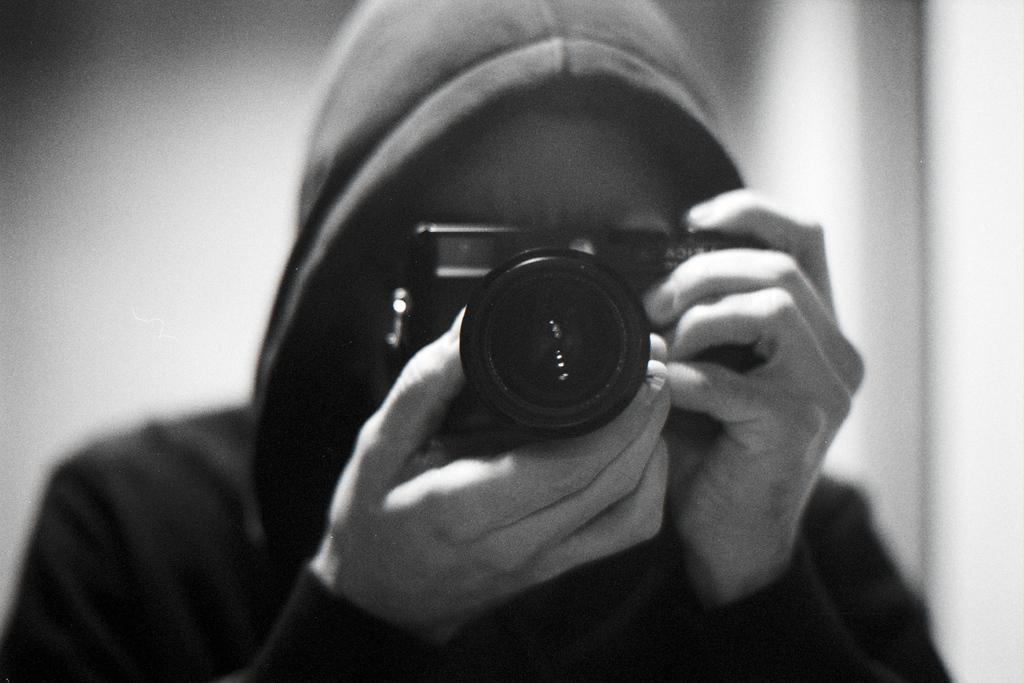What is the main subject of the image? There is a person in the image. What is the person wearing? The person is wearing a jacket. What is the person holding? The person is holding a camera. What is the person doing with the camera? The person is capturing a picture. What type of patch can be seen on the person's jacket in the image? There is no patch visible on the person's jacket in the image. What part of the camera is connected to a wire in the image? There is no wire connected to any part of the camera in the image. 